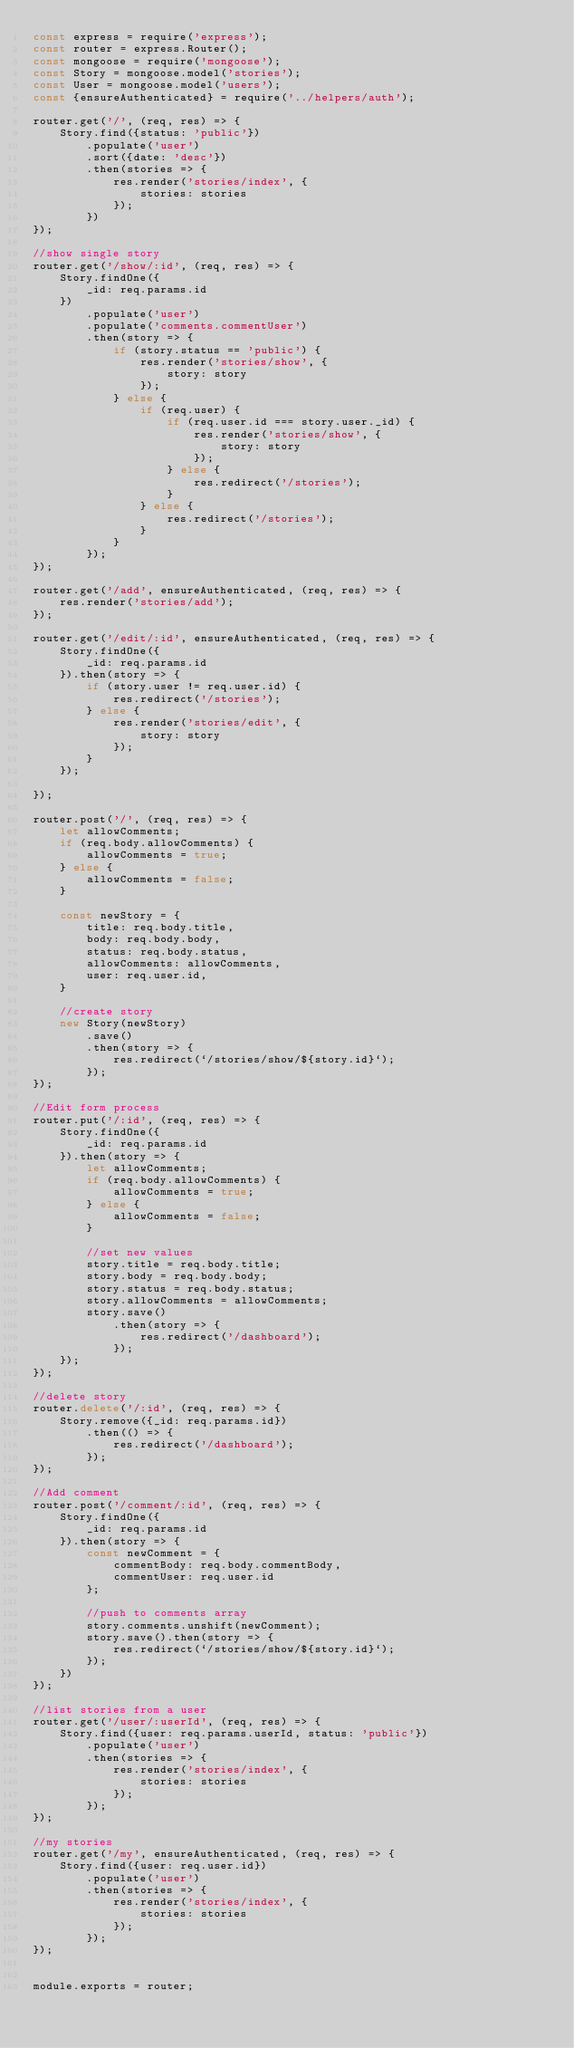Convert code to text. <code><loc_0><loc_0><loc_500><loc_500><_JavaScript_>const express = require('express');
const router = express.Router();
const mongoose = require('mongoose');
const Story = mongoose.model('stories');
const User = mongoose.model('users');
const {ensureAuthenticated} = require('../helpers/auth');

router.get('/', (req, res) => {
    Story.find({status: 'public'})
        .populate('user')
        .sort({date: 'desc'})
        .then(stories => {
            res.render('stories/index', {
                stories: stories
            });
        })
});

//show single story
router.get('/show/:id', (req, res) => {
    Story.findOne({
        _id: req.params.id
    })
        .populate('user')
        .populate('comments.commentUser')
        .then(story => {
            if (story.status == 'public') {
                res.render('stories/show', {
                    story: story
                });
            } else {
                if (req.user) {
                    if (req.user.id === story.user._id) {
                        res.render('stories/show', {
                            story: story
                        });
                    } else {
                        res.redirect('/stories');
                    }
                } else {
                    res.redirect('/stories');
                }
            }
        });
});

router.get('/add', ensureAuthenticated, (req, res) => {
    res.render('stories/add');
});

router.get('/edit/:id', ensureAuthenticated, (req, res) => {
    Story.findOne({
        _id: req.params.id
    }).then(story => {
        if (story.user != req.user.id) {
            res.redirect('/stories');
        } else {
            res.render('stories/edit', {
                story: story
            });
        }
    });

});

router.post('/', (req, res) => {
    let allowComments;
    if (req.body.allowComments) {
        allowComments = true;
    } else {
        allowComments = false;
    }

    const newStory = {
        title: req.body.title,
        body: req.body.body,
        status: req.body.status,
        allowComments: allowComments,
        user: req.user.id,
    }

    //create story
    new Story(newStory)
        .save()
        .then(story => {
            res.redirect(`/stories/show/${story.id}`);
        });
});

//Edit form process
router.put('/:id', (req, res) => {
    Story.findOne({
        _id: req.params.id
    }).then(story => {
        let allowComments;
        if (req.body.allowComments) {
            allowComments = true;
        } else {
            allowComments = false;
        }

        //set new values
        story.title = req.body.title;
        story.body = req.body.body;
        story.status = req.body.status;
        story.allowComments = allowComments;
        story.save()
            .then(story => {
                res.redirect('/dashboard');
            });
    });
});

//delete story
router.delete('/:id', (req, res) => {
    Story.remove({_id: req.params.id})
        .then(() => {
            res.redirect('/dashboard');
        });
});

//Add comment
router.post('/comment/:id', (req, res) => {
    Story.findOne({
        _id: req.params.id
    }).then(story => {
        const newComment = {
            commentBody: req.body.commentBody,
            commentUser: req.user.id
        };

        //push to comments array
        story.comments.unshift(newComment);
        story.save().then(story => {
            res.redirect(`/stories/show/${story.id}`);
        });
    })
});

//list stories from a user
router.get('/user/:userId', (req, res) => {
    Story.find({user: req.params.userId, status: 'public'})
        .populate('user')
        .then(stories => {
            res.render('stories/index', {
                stories: stories
            });
        });
});

//my stories
router.get('/my', ensureAuthenticated, (req, res) => {
    Story.find({user: req.user.id})
        .populate('user')
        .then(stories => {
            res.render('stories/index', {
                stories: stories
            });
        });
});


module.exports = router;</code> 